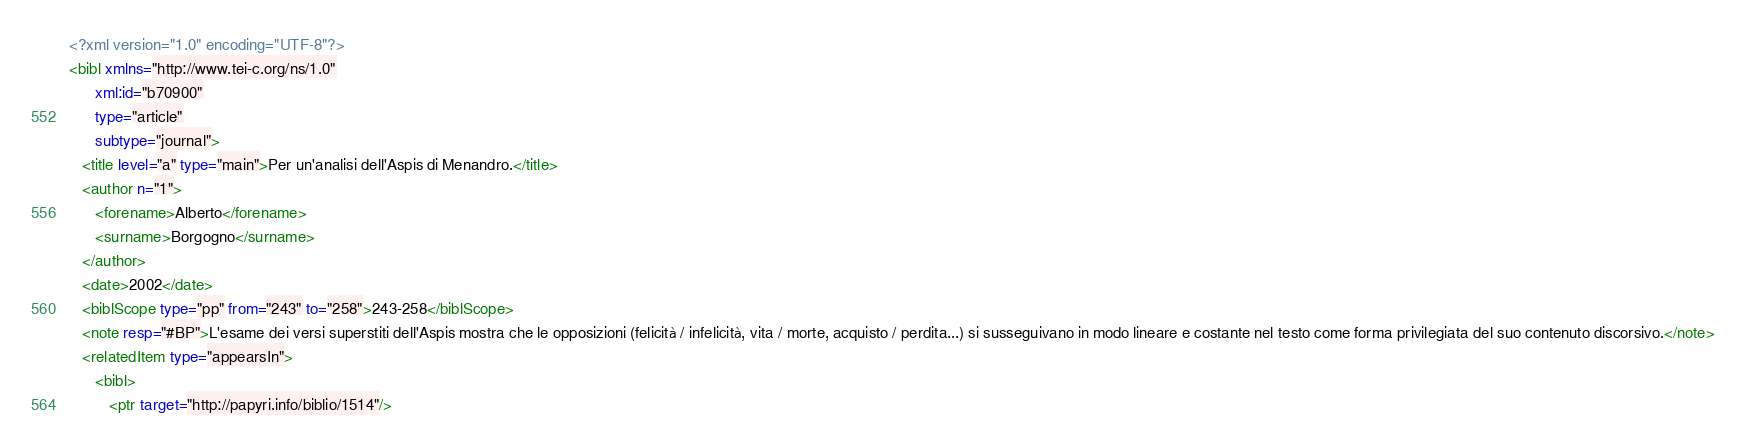<code> <loc_0><loc_0><loc_500><loc_500><_XML_><?xml version="1.0" encoding="UTF-8"?>
<bibl xmlns="http://www.tei-c.org/ns/1.0"
      xml:id="b70900"
      type="article"
      subtype="journal">
   <title level="a" type="main">Per un'analisi dell'Aspis di Menandro.</title>
   <author n="1">
      <forename>Alberto</forename>
      <surname>Borgogno</surname>
   </author>
   <date>2002</date>
   <biblScope type="pp" from="243" to="258">243-258</biblScope>
   <note resp="#BP">L'esame dei versi superstiti dell'Aspis mostra che le opposizioni (felicità / infelicità, vita / morte, acquisto / perdita...) si susseguivano in modo lineare e costante nel testo come forma privilegiata del suo contenuto discorsivo.</note>
   <relatedItem type="appearsIn">
      <bibl>
         <ptr target="http://papyri.info/biblio/1514"/></code> 